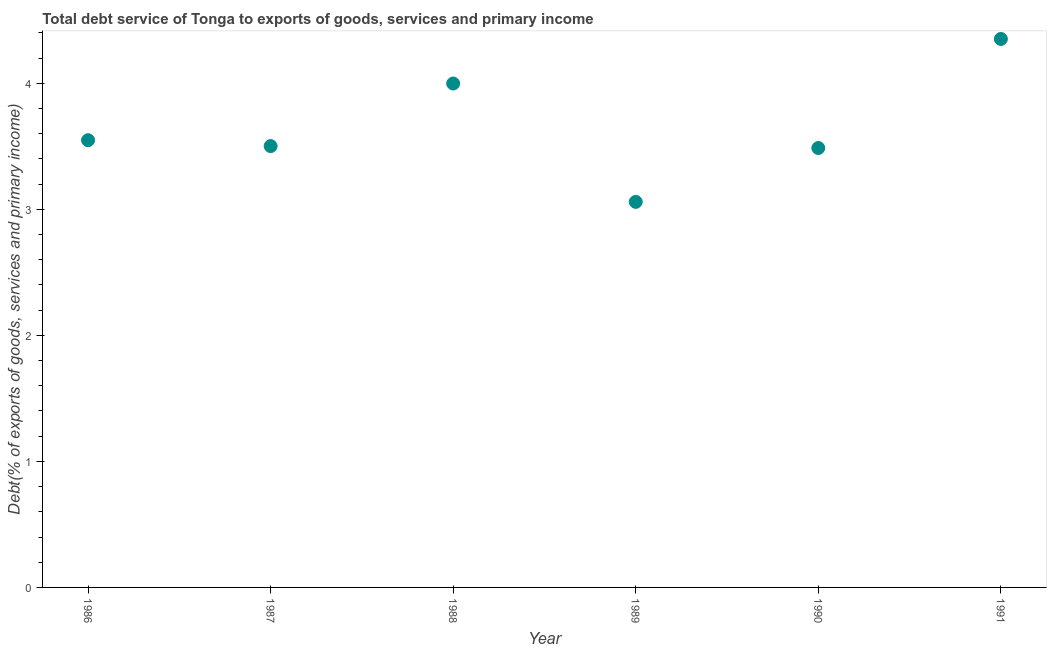What is the total debt service in 1990?
Your answer should be very brief. 3.49. Across all years, what is the maximum total debt service?
Your response must be concise. 4.35. Across all years, what is the minimum total debt service?
Your response must be concise. 3.06. In which year was the total debt service maximum?
Provide a short and direct response. 1991. In which year was the total debt service minimum?
Provide a succinct answer. 1989. What is the sum of the total debt service?
Offer a terse response. 21.94. What is the difference between the total debt service in 1986 and 1987?
Your answer should be compact. 0.05. What is the average total debt service per year?
Give a very brief answer. 3.66. What is the median total debt service?
Your response must be concise. 3.52. Do a majority of the years between 1991 and 1987 (inclusive) have total debt service greater than 4 %?
Provide a succinct answer. Yes. What is the ratio of the total debt service in 1988 to that in 1990?
Ensure brevity in your answer.  1.15. What is the difference between the highest and the second highest total debt service?
Your answer should be very brief. 0.35. What is the difference between the highest and the lowest total debt service?
Your answer should be very brief. 1.29. Does the total debt service monotonically increase over the years?
Keep it short and to the point. No. How many dotlines are there?
Provide a succinct answer. 1. How many years are there in the graph?
Offer a terse response. 6. What is the difference between two consecutive major ticks on the Y-axis?
Give a very brief answer. 1. Does the graph contain grids?
Give a very brief answer. No. What is the title of the graph?
Ensure brevity in your answer.  Total debt service of Tonga to exports of goods, services and primary income. What is the label or title of the Y-axis?
Provide a short and direct response. Debt(% of exports of goods, services and primary income). What is the Debt(% of exports of goods, services and primary income) in 1986?
Your response must be concise. 3.55. What is the Debt(% of exports of goods, services and primary income) in 1987?
Ensure brevity in your answer.  3.5. What is the Debt(% of exports of goods, services and primary income) in 1988?
Offer a terse response. 4. What is the Debt(% of exports of goods, services and primary income) in 1989?
Ensure brevity in your answer.  3.06. What is the Debt(% of exports of goods, services and primary income) in 1990?
Provide a short and direct response. 3.49. What is the Debt(% of exports of goods, services and primary income) in 1991?
Ensure brevity in your answer.  4.35. What is the difference between the Debt(% of exports of goods, services and primary income) in 1986 and 1987?
Your answer should be compact. 0.05. What is the difference between the Debt(% of exports of goods, services and primary income) in 1986 and 1988?
Give a very brief answer. -0.45. What is the difference between the Debt(% of exports of goods, services and primary income) in 1986 and 1989?
Ensure brevity in your answer.  0.49. What is the difference between the Debt(% of exports of goods, services and primary income) in 1986 and 1990?
Make the answer very short. 0.06. What is the difference between the Debt(% of exports of goods, services and primary income) in 1986 and 1991?
Give a very brief answer. -0.8. What is the difference between the Debt(% of exports of goods, services and primary income) in 1987 and 1988?
Your response must be concise. -0.5. What is the difference between the Debt(% of exports of goods, services and primary income) in 1987 and 1989?
Provide a short and direct response. 0.44. What is the difference between the Debt(% of exports of goods, services and primary income) in 1987 and 1990?
Your answer should be very brief. 0.02. What is the difference between the Debt(% of exports of goods, services and primary income) in 1987 and 1991?
Ensure brevity in your answer.  -0.85. What is the difference between the Debt(% of exports of goods, services and primary income) in 1988 and 1989?
Make the answer very short. 0.94. What is the difference between the Debt(% of exports of goods, services and primary income) in 1988 and 1990?
Make the answer very short. 0.51. What is the difference between the Debt(% of exports of goods, services and primary income) in 1988 and 1991?
Keep it short and to the point. -0.35. What is the difference between the Debt(% of exports of goods, services and primary income) in 1989 and 1990?
Keep it short and to the point. -0.43. What is the difference between the Debt(% of exports of goods, services and primary income) in 1989 and 1991?
Your answer should be very brief. -1.29. What is the difference between the Debt(% of exports of goods, services and primary income) in 1990 and 1991?
Give a very brief answer. -0.87. What is the ratio of the Debt(% of exports of goods, services and primary income) in 1986 to that in 1988?
Your answer should be very brief. 0.89. What is the ratio of the Debt(% of exports of goods, services and primary income) in 1986 to that in 1989?
Ensure brevity in your answer.  1.16. What is the ratio of the Debt(% of exports of goods, services and primary income) in 1986 to that in 1991?
Make the answer very short. 0.81. What is the ratio of the Debt(% of exports of goods, services and primary income) in 1987 to that in 1988?
Give a very brief answer. 0.88. What is the ratio of the Debt(% of exports of goods, services and primary income) in 1987 to that in 1989?
Offer a terse response. 1.15. What is the ratio of the Debt(% of exports of goods, services and primary income) in 1987 to that in 1990?
Offer a very short reply. 1. What is the ratio of the Debt(% of exports of goods, services and primary income) in 1987 to that in 1991?
Ensure brevity in your answer.  0.81. What is the ratio of the Debt(% of exports of goods, services and primary income) in 1988 to that in 1989?
Ensure brevity in your answer.  1.31. What is the ratio of the Debt(% of exports of goods, services and primary income) in 1988 to that in 1990?
Provide a succinct answer. 1.15. What is the ratio of the Debt(% of exports of goods, services and primary income) in 1988 to that in 1991?
Make the answer very short. 0.92. What is the ratio of the Debt(% of exports of goods, services and primary income) in 1989 to that in 1990?
Your answer should be compact. 0.88. What is the ratio of the Debt(% of exports of goods, services and primary income) in 1989 to that in 1991?
Make the answer very short. 0.7. What is the ratio of the Debt(% of exports of goods, services and primary income) in 1990 to that in 1991?
Your answer should be very brief. 0.8. 